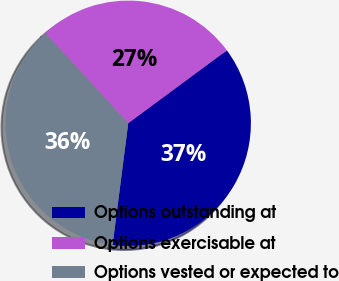Convert chart to OTSL. <chart><loc_0><loc_0><loc_500><loc_500><pie_chart><fcel>Options outstanding at<fcel>Options exercisable at<fcel>Options vested or expected to<nl><fcel>37.16%<fcel>26.71%<fcel>36.14%<nl></chart> 